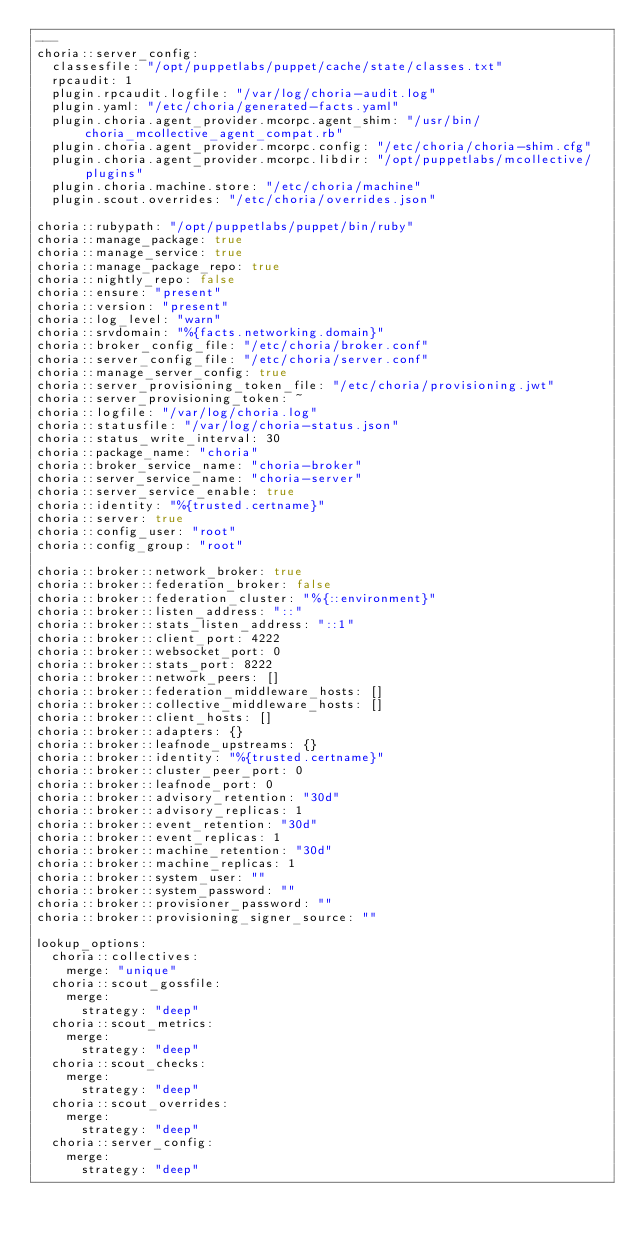Convert code to text. <code><loc_0><loc_0><loc_500><loc_500><_YAML_>---
choria::server_config:
  classesfile: "/opt/puppetlabs/puppet/cache/state/classes.txt"
  rpcaudit: 1
  plugin.rpcaudit.logfile: "/var/log/choria-audit.log"
  plugin.yaml: "/etc/choria/generated-facts.yaml"
  plugin.choria.agent_provider.mcorpc.agent_shim: "/usr/bin/choria_mcollective_agent_compat.rb"
  plugin.choria.agent_provider.mcorpc.config: "/etc/choria/choria-shim.cfg"
  plugin.choria.agent_provider.mcorpc.libdir: "/opt/puppetlabs/mcollective/plugins"
  plugin.choria.machine.store: "/etc/choria/machine"
  plugin.scout.overrides: "/etc/choria/overrides.json"

choria::rubypath: "/opt/puppetlabs/puppet/bin/ruby"
choria::manage_package: true
choria::manage_service: true
choria::manage_package_repo: true
choria::nightly_repo: false
choria::ensure: "present"
choria::version: "present"
choria::log_level: "warn"
choria::srvdomain: "%{facts.networking.domain}"
choria::broker_config_file: "/etc/choria/broker.conf"
choria::server_config_file: "/etc/choria/server.conf"
choria::manage_server_config: true
choria::server_provisioning_token_file: "/etc/choria/provisioning.jwt"
choria::server_provisioning_token: ~
choria::logfile: "/var/log/choria.log"
choria::statusfile: "/var/log/choria-status.json"
choria::status_write_interval: 30
choria::package_name: "choria"
choria::broker_service_name: "choria-broker"
choria::server_service_name: "choria-server"
choria::server_service_enable: true
choria::identity: "%{trusted.certname}"
choria::server: true
choria::config_user: "root"
choria::config_group: "root"

choria::broker::network_broker: true
choria::broker::federation_broker: false
choria::broker::federation_cluster: "%{::environment}"
choria::broker::listen_address: "::"
choria::broker::stats_listen_address: "::1"
choria::broker::client_port: 4222
choria::broker::websocket_port: 0
choria::broker::stats_port: 8222
choria::broker::network_peers: []
choria::broker::federation_middleware_hosts: []
choria::broker::collective_middleware_hosts: []
choria::broker::client_hosts: []
choria::broker::adapters: {}
choria::broker::leafnode_upstreams: {}
choria::broker::identity: "%{trusted.certname}"
choria::broker::cluster_peer_port: 0
choria::broker::leafnode_port: 0
choria::broker::advisory_retention: "30d"
choria::broker::advisory_replicas: 1
choria::broker::event_retention: "30d"
choria::broker::event_replicas: 1
choria::broker::machine_retention: "30d"
choria::broker::machine_replicas: 1
choria::broker::system_user: ""
choria::broker::system_password: ""
choria::broker::provisioner_password: ""
choria::broker::provisioning_signer_source: ""

lookup_options:
  choria::collectives:
    merge: "unique"
  choria::scout_gossfile:
    merge:
      strategy: "deep"
  choria::scout_metrics:
    merge:
      strategy: "deep"
  choria::scout_checks:
    merge:
      strategy: "deep"
  choria::scout_overrides:
    merge:
      strategy: "deep"
  choria::server_config:
    merge:
      strategy: "deep"
</code> 